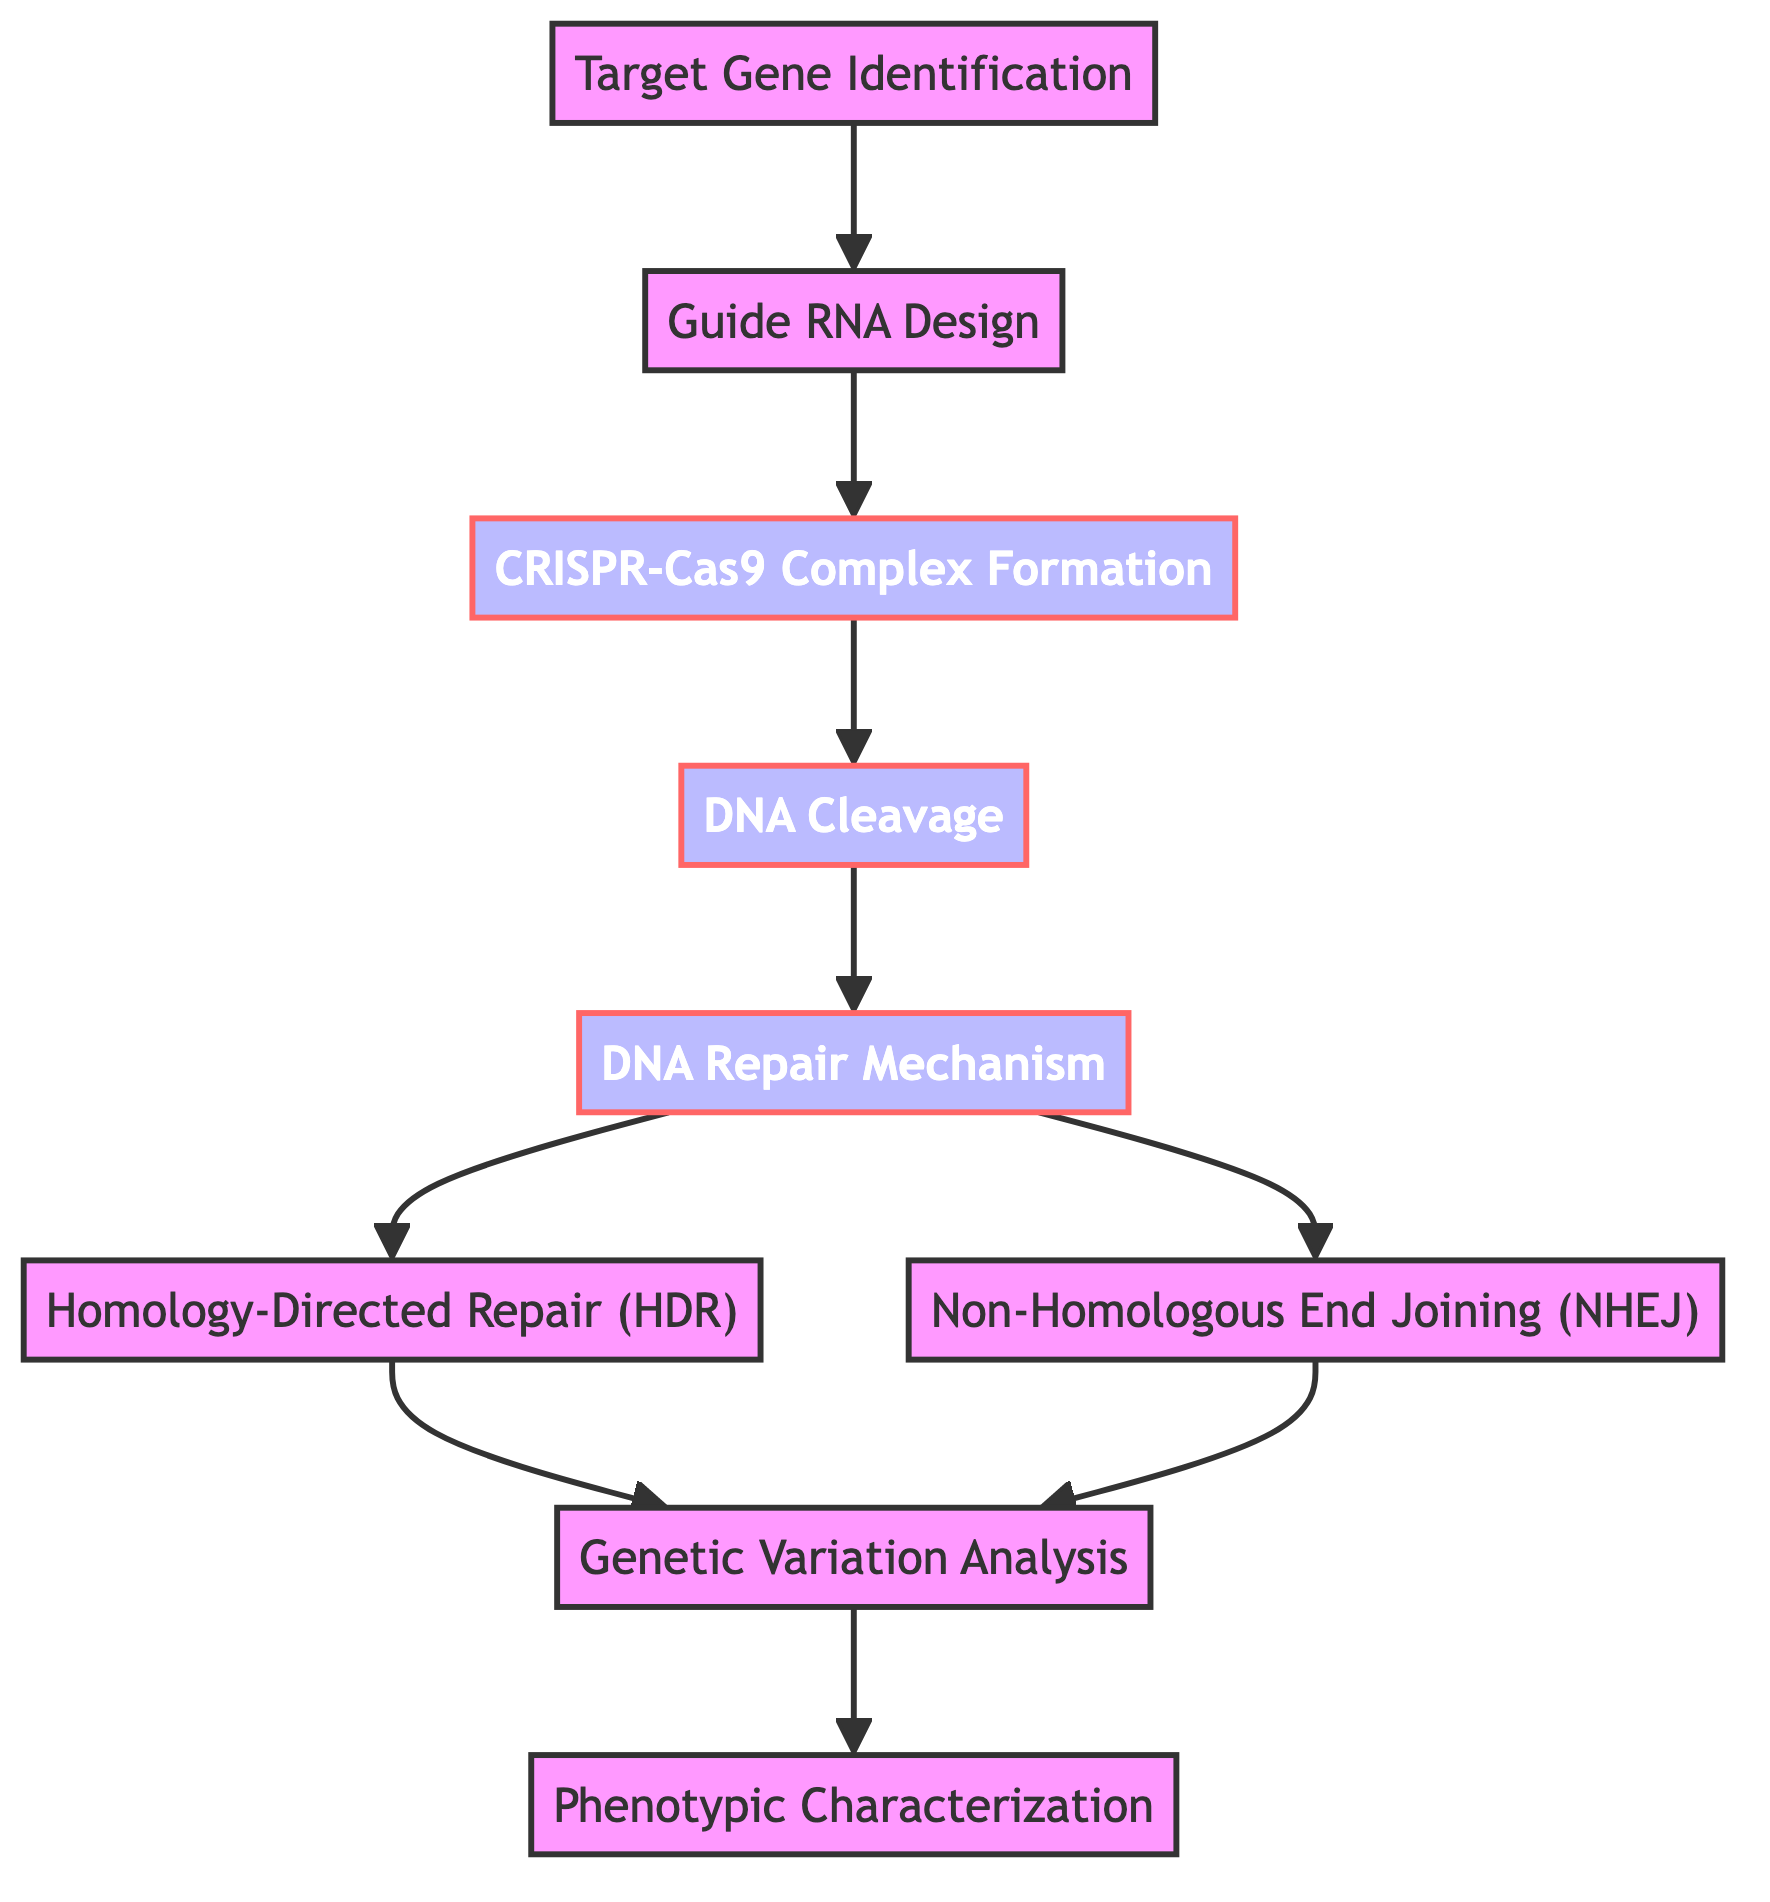What is the first step in the genome editing process? The first step is "Target Gene Identification," which is the starting point of the flow in the diagram.
Answer: Target Gene Identification How many nodes are there in the diagram? By counting the listed nodes in the data, I find there are 9 nodes representing distinct steps in the genome editing process.
Answer: 9 What is the relationship between "DNA Cleavage" and "DNA Repair Mechanism"? "DNA Cleavage" leads directly to "DNA Repair Mechanism," which means that once the DNA is cleaved, the subsequent step is the activation of the DNA repair process.
Answer: Directly leads to Which nodes follow the "Guide RNA Design" in the flow? After "Guide RNA Design," the next node is "CRISPR-Cas9 Complex Formation," continuing to "DNA Cleavage." Thus, these nodes are sequentially linked.
Answer: CRISPR-Cas9 Complex Formation, DNA Cleavage What happens after "DNA Repair Mechanism"? Following "DNA Repair Mechanism," two possible pathways emerge: it can lead to either "Homology-Directed Repair" or "Non-Homologous End Joining," which are options for repair mechanisms.
Answer: Homology-Directed Repair, Non-Homologous End Joining How many edges are connected to "Genetic Variation Analysis"? By examining the flow and connections, "Genetic Variation Analysis" has one incoming edge from both repair mechanisms and then moves on to "Phenotypic Characterization," totaling two edges.
Answer: 2 What are the outcomes of the "Homology-Directed Repair" step? Following "Homology-Directed Repair," the next step is "Genetic Variation Analysis," indicating that this method leads to assessing genetic variations.
Answer: Genetic Variation Analysis Which step involves the formation of the CRISPR-Cas9 complex? The step involving the creation of the CRISPR-Cas9 complex is "CRISPR-Cas9 Complex Formation," which comes after designing the guide RNA.
Answer: CRISPR-Cas9 Complex Formation What do the outcomes from both repair types lead to? Both "Homology-Directed Repair" and "Non-Homologous End Joining" ultimately lead to "Genetic Variation Analysis," signifying that different repair mechanisms result in analyzing genetic variations.
Answer: Genetic Variation Analysis 